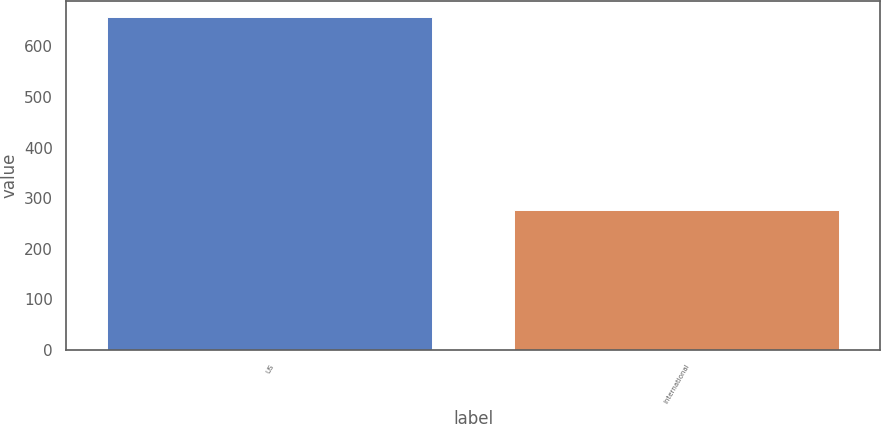Convert chart. <chart><loc_0><loc_0><loc_500><loc_500><bar_chart><fcel>US<fcel>International<nl><fcel>658<fcel>276<nl></chart> 